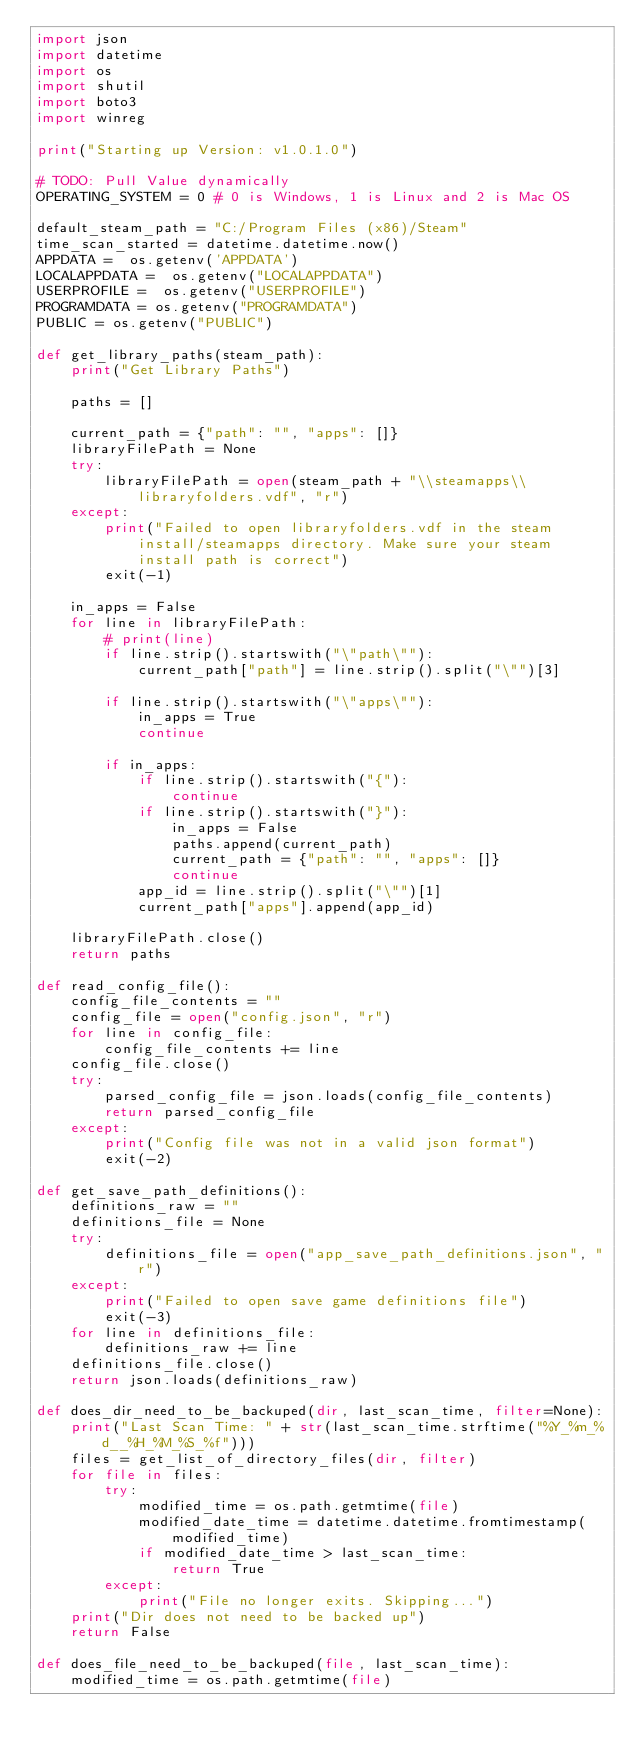<code> <loc_0><loc_0><loc_500><loc_500><_Python_>import json
import datetime
import os
import shutil
import boto3
import winreg

print("Starting up Version: v1.0.1.0")

# TODO: Pull Value dynamically
OPERATING_SYSTEM = 0 # 0 is Windows, 1 is Linux and 2 is Mac OS

default_steam_path = "C:/Program Files (x86)/Steam"
time_scan_started = datetime.datetime.now()
APPDATA =  os.getenv('APPDATA')
LOCALAPPDATA =  os.getenv("LOCALAPPDATA")
USERPROFILE =  os.getenv("USERPROFILE")
PROGRAMDATA = os.getenv("PROGRAMDATA")
PUBLIC = os.getenv("PUBLIC")

def get_library_paths(steam_path):
    print("Get Library Paths")

    paths = []

    current_path = {"path": "", "apps": []}
    libraryFilePath = None
    try:
        libraryFilePath = open(steam_path + "\\steamapps\\libraryfolders.vdf", "r")
    except:
        print("Failed to open libraryfolders.vdf in the steam install/steamapps directory. Make sure your steam install path is correct")
        exit(-1)

    in_apps = False
    for line in libraryFilePath:
        # print(line)
        if line.strip().startswith("\"path\""):
            current_path["path"] = line.strip().split("\"")[3]

        if line.strip().startswith("\"apps\""):
            in_apps = True
            continue

        if in_apps:
            if line.strip().startswith("{"):
                continue
            if line.strip().startswith("}"):
                in_apps = False
                paths.append(current_path)
                current_path = {"path": "", "apps": []}
                continue
            app_id = line.strip().split("\"")[1]
            current_path["apps"].append(app_id)

    libraryFilePath.close()
    return paths

def read_config_file():
    config_file_contents = ""
    config_file = open("config.json", "r")
    for line in config_file:
        config_file_contents += line
    config_file.close()
    try:
        parsed_config_file = json.loads(config_file_contents)
        return parsed_config_file
    except:
        print("Config file was not in a valid json format")
        exit(-2)

def get_save_path_definitions():
    definitions_raw = ""
    definitions_file = None
    try:
        definitions_file = open("app_save_path_definitions.json", "r")
    except:
        print("Failed to open save game definitions file")
        exit(-3)
    for line in definitions_file:
        definitions_raw += line
    definitions_file.close()
    return json.loads(definitions_raw)

def does_dir_need_to_be_backuped(dir, last_scan_time, filter=None):
    print("Last Scan Time: " + str(last_scan_time.strftime("%Y_%m_%d__%H_%M_%S_%f")))
    files = get_list_of_directory_files(dir, filter)
    for file in files:
        try:
            modified_time = os.path.getmtime(file)
            modified_date_time = datetime.datetime.fromtimestamp(modified_time)
            if modified_date_time > last_scan_time:
                return True
        except:
            print("File no longer exits. Skipping...")
    print("Dir does not need to be backed up")
    return False

def does_file_need_to_be_backuped(file, last_scan_time):
    modified_time = os.path.getmtime(file)</code> 